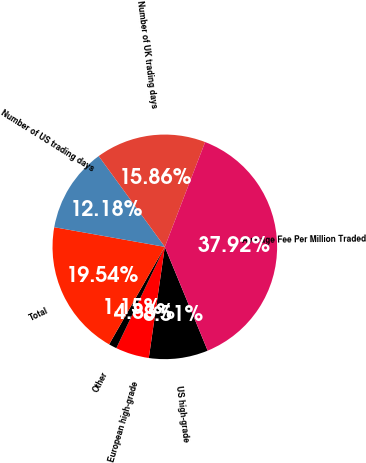Convert chart. <chart><loc_0><loc_0><loc_500><loc_500><pie_chart><fcel>US high-grade<fcel>European high-grade<fcel>Other<fcel>Total<fcel>Number of US trading days<fcel>Number of UK trading days<fcel>Average Fee Per Million Traded<nl><fcel>8.51%<fcel>4.83%<fcel>1.15%<fcel>19.54%<fcel>12.18%<fcel>15.86%<fcel>37.92%<nl></chart> 